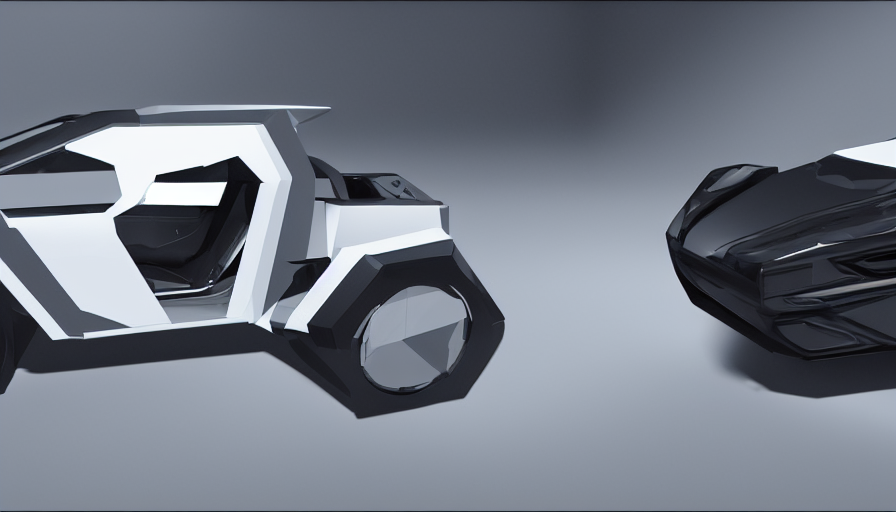Can you describe the lighting and mood this image conveys? The image is bathed in a soft, diffuse light that gives it a sleek and modern feel. The neutral, almost monochromatic color palette contributes to a calm and serene mood. There is a subtle interplay of light and shadow that suggests a quiet, almost contemplative atmosphere, emphasizing the futuristic design of the objects portrayed. 